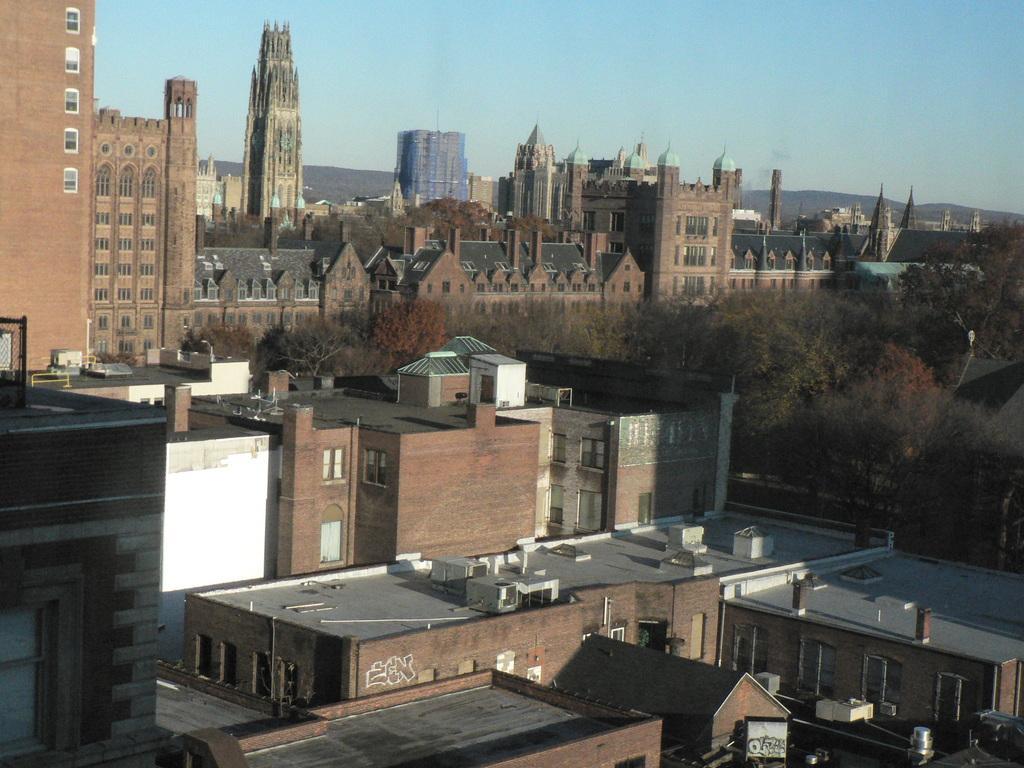How would you summarize this image in a sentence or two? In this image I can see buildings, trees, towers, mountains and the sky. This image is taken may be during a day. 